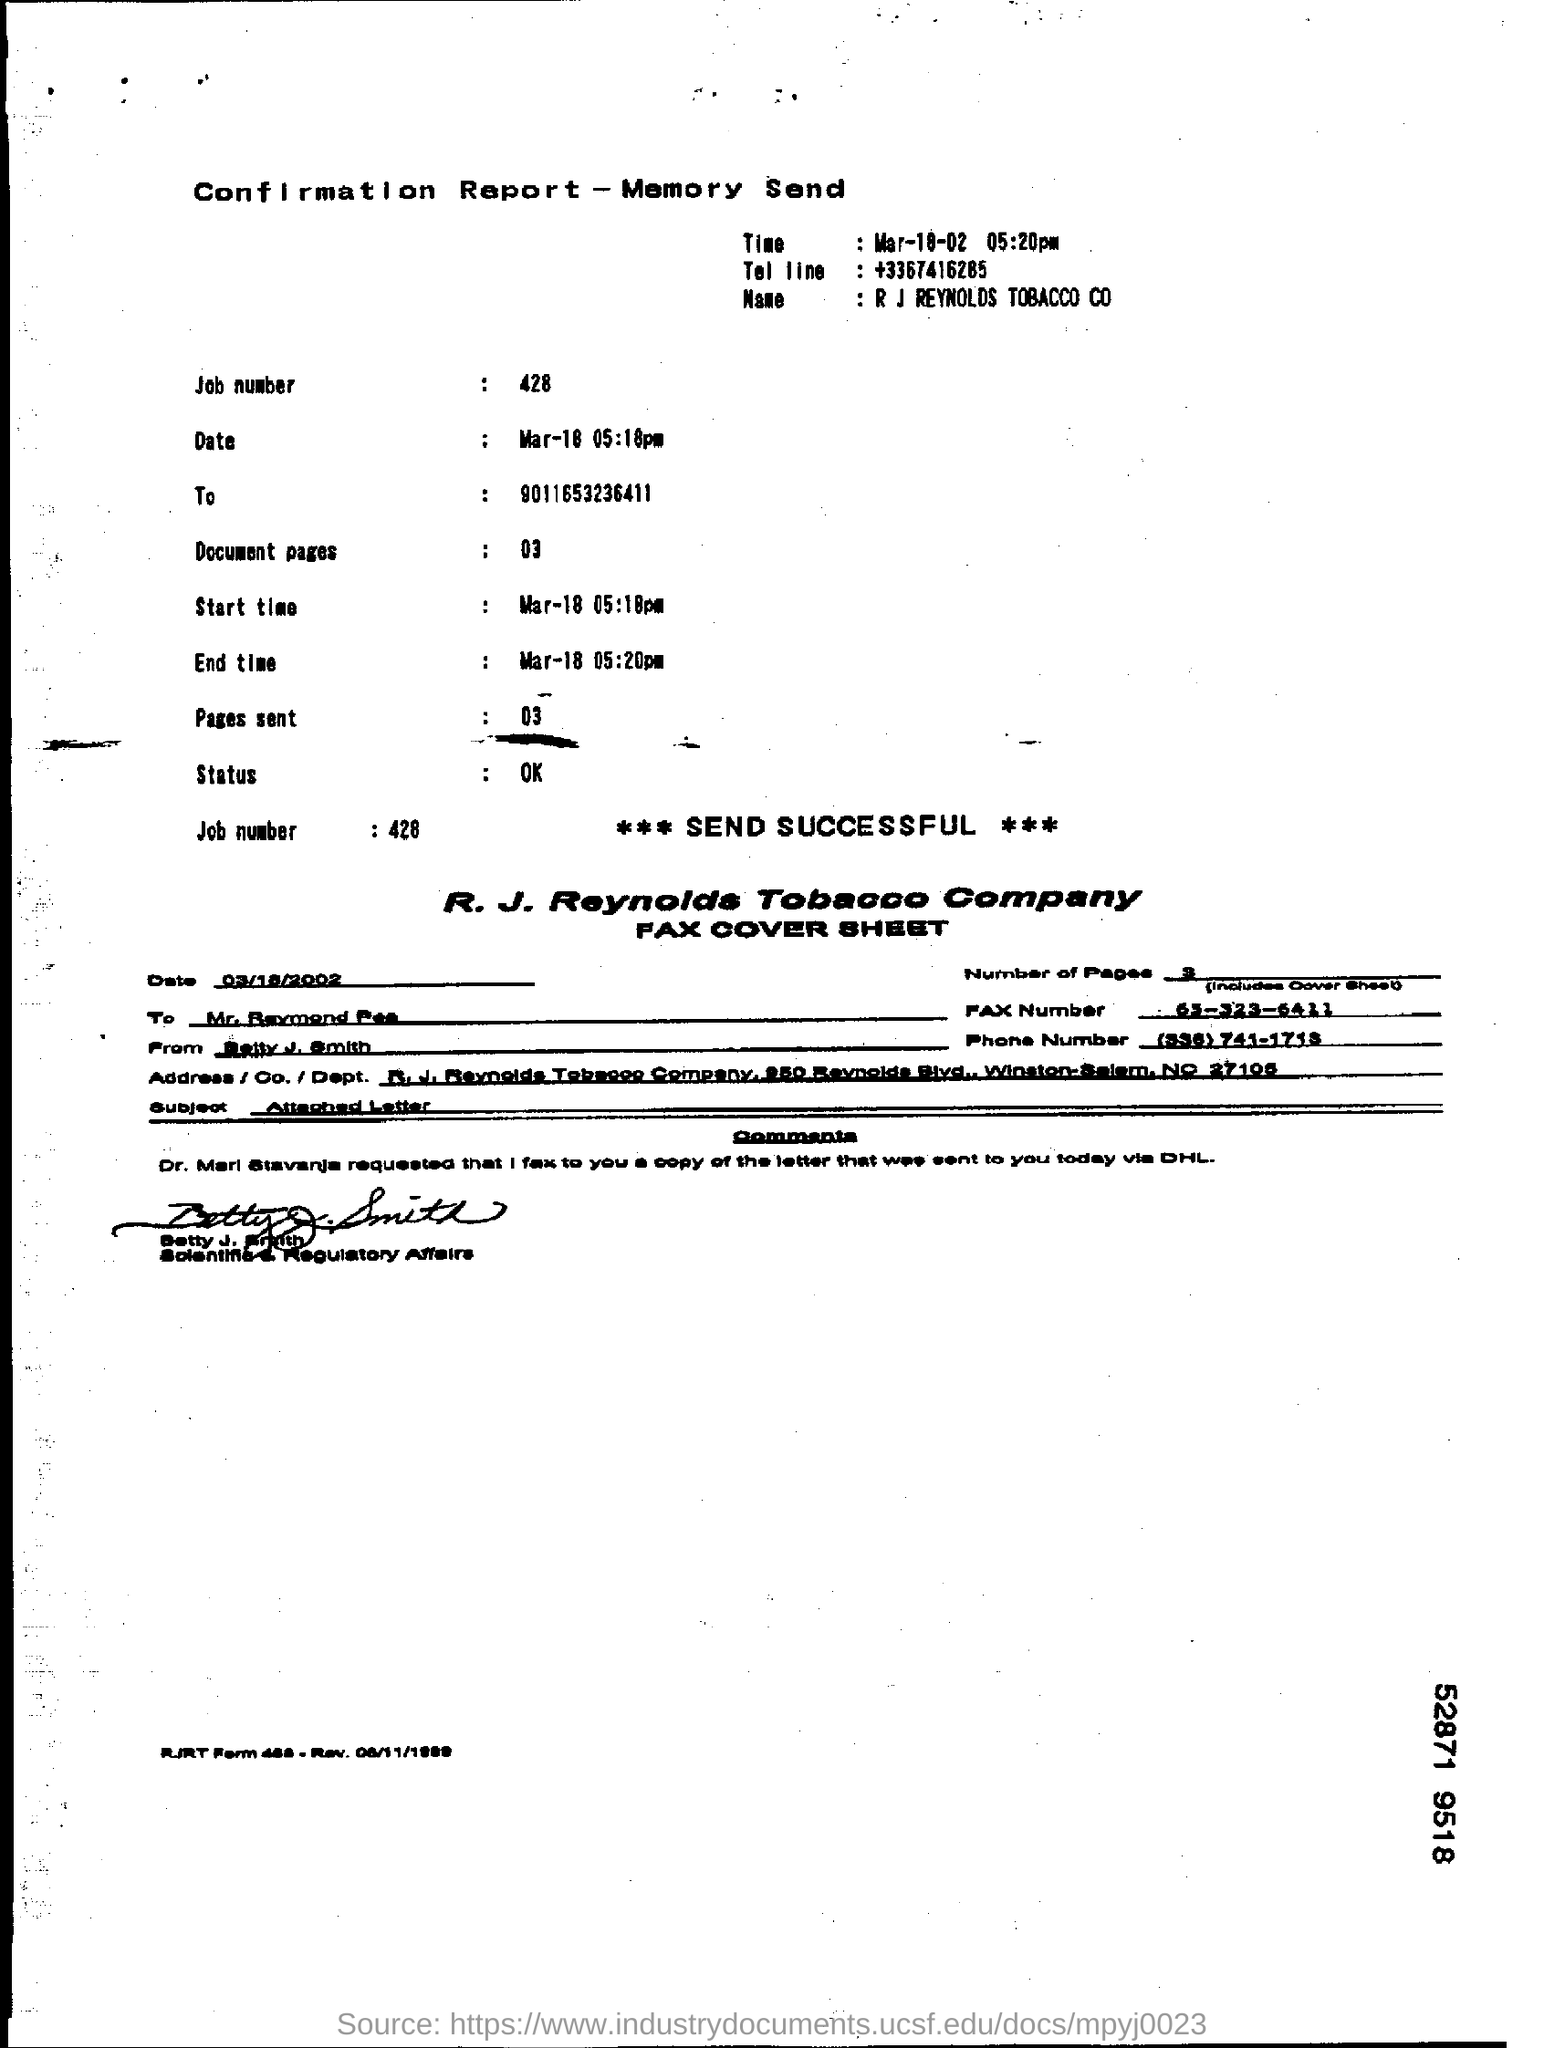What is the job number?
Ensure brevity in your answer.  428. What is the subject of the fax cover sheet?
Make the answer very short. Attached Letter. 